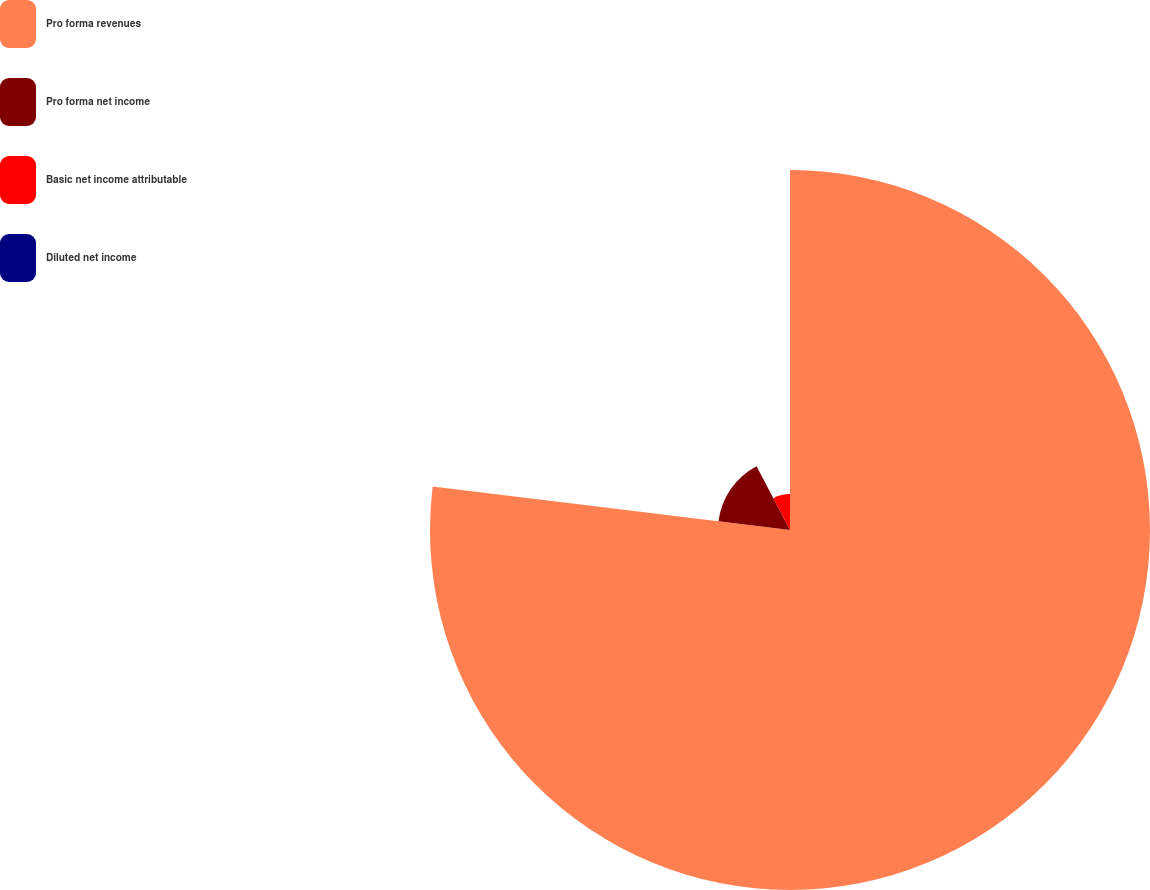Convert chart. <chart><loc_0><loc_0><loc_500><loc_500><pie_chart><fcel>Pro forma revenues<fcel>Pro forma net income<fcel>Basic net income attributable<fcel>Diluted net income<nl><fcel>76.92%<fcel>15.38%<fcel>7.69%<fcel>0.0%<nl></chart> 